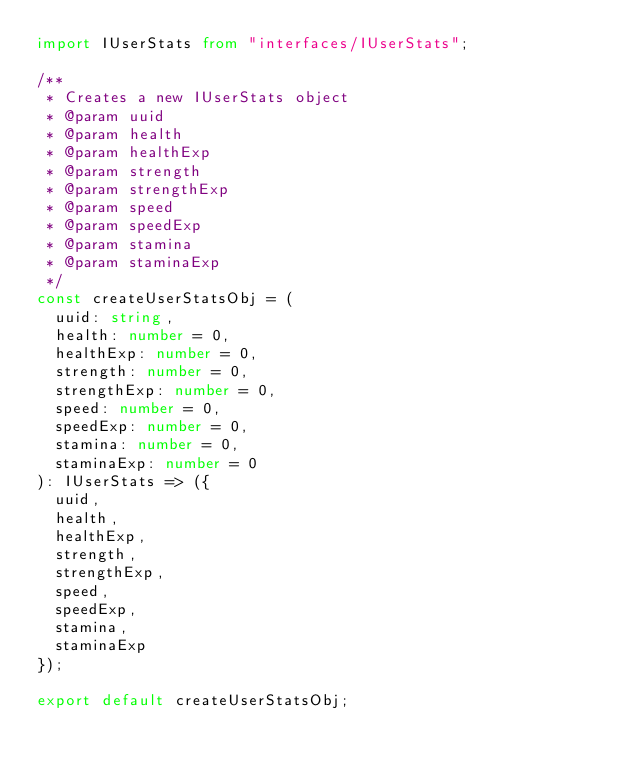<code> <loc_0><loc_0><loc_500><loc_500><_TypeScript_>import IUserStats from "interfaces/IUserStats";

/**
 * Creates a new IUserStats object
 * @param uuid
 * @param health
 * @param healthExp
 * @param strength
 * @param strengthExp
 * @param speed
 * @param speedExp
 * @param stamina
 * @param staminaExp
 */
const createUserStatsObj = (
  uuid: string,
  health: number = 0,
  healthExp: number = 0,
  strength: number = 0,
  strengthExp: number = 0,
  speed: number = 0,
  speedExp: number = 0,
  stamina: number = 0,
  staminaExp: number = 0
): IUserStats => ({
  uuid,
  health,
  healthExp,
  strength,
  strengthExp,
  speed,
  speedExp,
  stamina,
  staminaExp
});

export default createUserStatsObj;
</code> 